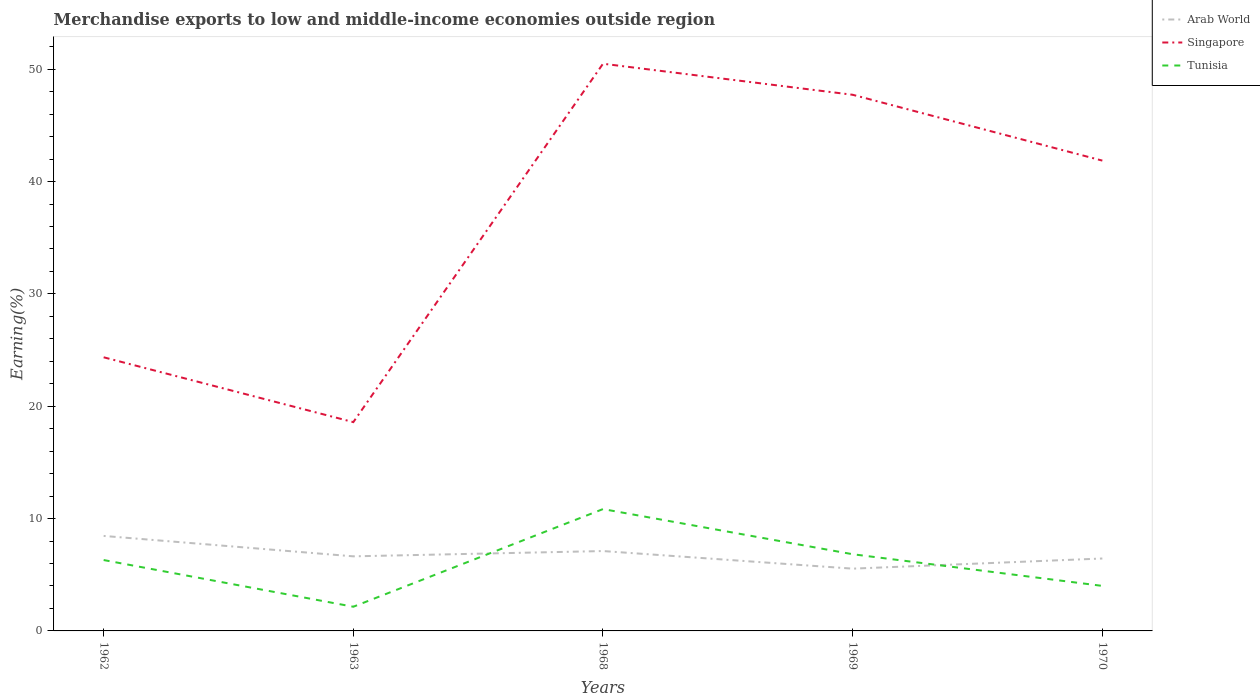How many different coloured lines are there?
Your answer should be very brief. 3. Does the line corresponding to Singapore intersect with the line corresponding to Arab World?
Make the answer very short. No. Across all years, what is the maximum percentage of amount earned from merchandise exports in Singapore?
Make the answer very short. 18.59. In which year was the percentage of amount earned from merchandise exports in Singapore maximum?
Offer a very short reply. 1963. What is the total percentage of amount earned from merchandise exports in Arab World in the graph?
Ensure brevity in your answer.  2.91. What is the difference between the highest and the second highest percentage of amount earned from merchandise exports in Singapore?
Your answer should be very brief. 31.9. Does the graph contain any zero values?
Give a very brief answer. No. Where does the legend appear in the graph?
Keep it short and to the point. Top right. How many legend labels are there?
Offer a terse response. 3. What is the title of the graph?
Offer a very short reply. Merchandise exports to low and middle-income economies outside region. Does "Cayman Islands" appear as one of the legend labels in the graph?
Your answer should be compact. No. What is the label or title of the X-axis?
Provide a short and direct response. Years. What is the label or title of the Y-axis?
Make the answer very short. Earning(%). What is the Earning(%) of Arab World in 1962?
Offer a very short reply. 8.46. What is the Earning(%) of Singapore in 1962?
Keep it short and to the point. 24.36. What is the Earning(%) in Tunisia in 1962?
Your answer should be compact. 6.31. What is the Earning(%) of Arab World in 1963?
Offer a very short reply. 6.64. What is the Earning(%) in Singapore in 1963?
Offer a very short reply. 18.59. What is the Earning(%) in Tunisia in 1963?
Your answer should be very brief. 2.15. What is the Earning(%) of Arab World in 1968?
Ensure brevity in your answer.  7.11. What is the Earning(%) of Singapore in 1968?
Make the answer very short. 50.49. What is the Earning(%) of Tunisia in 1968?
Your answer should be compact. 10.85. What is the Earning(%) in Arab World in 1969?
Keep it short and to the point. 5.54. What is the Earning(%) of Singapore in 1969?
Make the answer very short. 47.73. What is the Earning(%) in Tunisia in 1969?
Offer a very short reply. 6.83. What is the Earning(%) of Arab World in 1970?
Your answer should be compact. 6.45. What is the Earning(%) in Singapore in 1970?
Make the answer very short. 41.87. What is the Earning(%) in Tunisia in 1970?
Your answer should be compact. 4.01. Across all years, what is the maximum Earning(%) in Arab World?
Ensure brevity in your answer.  8.46. Across all years, what is the maximum Earning(%) in Singapore?
Make the answer very short. 50.49. Across all years, what is the maximum Earning(%) of Tunisia?
Provide a short and direct response. 10.85. Across all years, what is the minimum Earning(%) of Arab World?
Your answer should be compact. 5.54. Across all years, what is the minimum Earning(%) of Singapore?
Offer a very short reply. 18.59. Across all years, what is the minimum Earning(%) of Tunisia?
Provide a short and direct response. 2.15. What is the total Earning(%) in Arab World in the graph?
Your answer should be very brief. 34.2. What is the total Earning(%) in Singapore in the graph?
Offer a very short reply. 183.04. What is the total Earning(%) of Tunisia in the graph?
Keep it short and to the point. 30.14. What is the difference between the Earning(%) in Arab World in 1962 and that in 1963?
Your answer should be compact. 1.82. What is the difference between the Earning(%) of Singapore in 1962 and that in 1963?
Provide a succinct answer. 5.77. What is the difference between the Earning(%) of Tunisia in 1962 and that in 1963?
Keep it short and to the point. 4.16. What is the difference between the Earning(%) of Arab World in 1962 and that in 1968?
Offer a very short reply. 1.35. What is the difference between the Earning(%) in Singapore in 1962 and that in 1968?
Your answer should be very brief. -26.13. What is the difference between the Earning(%) in Tunisia in 1962 and that in 1968?
Keep it short and to the point. -4.54. What is the difference between the Earning(%) in Arab World in 1962 and that in 1969?
Provide a short and direct response. 2.91. What is the difference between the Earning(%) in Singapore in 1962 and that in 1969?
Give a very brief answer. -23.37. What is the difference between the Earning(%) in Tunisia in 1962 and that in 1969?
Give a very brief answer. -0.52. What is the difference between the Earning(%) in Arab World in 1962 and that in 1970?
Make the answer very short. 2.01. What is the difference between the Earning(%) in Singapore in 1962 and that in 1970?
Make the answer very short. -17.51. What is the difference between the Earning(%) in Tunisia in 1962 and that in 1970?
Your response must be concise. 2.3. What is the difference between the Earning(%) of Arab World in 1963 and that in 1968?
Give a very brief answer. -0.47. What is the difference between the Earning(%) in Singapore in 1963 and that in 1968?
Offer a very short reply. -31.9. What is the difference between the Earning(%) in Tunisia in 1963 and that in 1968?
Make the answer very short. -8.69. What is the difference between the Earning(%) of Arab World in 1963 and that in 1969?
Your answer should be very brief. 1.1. What is the difference between the Earning(%) in Singapore in 1963 and that in 1969?
Offer a terse response. -29.14. What is the difference between the Earning(%) of Tunisia in 1963 and that in 1969?
Your answer should be very brief. -4.67. What is the difference between the Earning(%) of Arab World in 1963 and that in 1970?
Ensure brevity in your answer.  0.19. What is the difference between the Earning(%) in Singapore in 1963 and that in 1970?
Your answer should be very brief. -23.28. What is the difference between the Earning(%) of Tunisia in 1963 and that in 1970?
Your answer should be very brief. -1.86. What is the difference between the Earning(%) in Arab World in 1968 and that in 1969?
Your answer should be very brief. 1.57. What is the difference between the Earning(%) of Singapore in 1968 and that in 1969?
Your answer should be very brief. 2.76. What is the difference between the Earning(%) in Tunisia in 1968 and that in 1969?
Offer a very short reply. 4.02. What is the difference between the Earning(%) in Arab World in 1968 and that in 1970?
Provide a short and direct response. 0.66. What is the difference between the Earning(%) in Singapore in 1968 and that in 1970?
Your answer should be very brief. 8.62. What is the difference between the Earning(%) in Tunisia in 1968 and that in 1970?
Provide a short and direct response. 6.84. What is the difference between the Earning(%) of Arab World in 1969 and that in 1970?
Offer a very short reply. -0.9. What is the difference between the Earning(%) of Singapore in 1969 and that in 1970?
Give a very brief answer. 5.86. What is the difference between the Earning(%) in Tunisia in 1969 and that in 1970?
Offer a very short reply. 2.82. What is the difference between the Earning(%) of Arab World in 1962 and the Earning(%) of Singapore in 1963?
Offer a terse response. -10.13. What is the difference between the Earning(%) in Arab World in 1962 and the Earning(%) in Tunisia in 1963?
Offer a very short reply. 6.3. What is the difference between the Earning(%) of Singapore in 1962 and the Earning(%) of Tunisia in 1963?
Your response must be concise. 22.21. What is the difference between the Earning(%) of Arab World in 1962 and the Earning(%) of Singapore in 1968?
Provide a succinct answer. -42.04. What is the difference between the Earning(%) in Arab World in 1962 and the Earning(%) in Tunisia in 1968?
Make the answer very short. -2.39. What is the difference between the Earning(%) in Singapore in 1962 and the Earning(%) in Tunisia in 1968?
Your response must be concise. 13.51. What is the difference between the Earning(%) of Arab World in 1962 and the Earning(%) of Singapore in 1969?
Offer a terse response. -39.27. What is the difference between the Earning(%) in Arab World in 1962 and the Earning(%) in Tunisia in 1969?
Provide a short and direct response. 1.63. What is the difference between the Earning(%) of Singapore in 1962 and the Earning(%) of Tunisia in 1969?
Your response must be concise. 17.53. What is the difference between the Earning(%) of Arab World in 1962 and the Earning(%) of Singapore in 1970?
Make the answer very short. -33.41. What is the difference between the Earning(%) in Arab World in 1962 and the Earning(%) in Tunisia in 1970?
Provide a short and direct response. 4.45. What is the difference between the Earning(%) in Singapore in 1962 and the Earning(%) in Tunisia in 1970?
Offer a very short reply. 20.35. What is the difference between the Earning(%) of Arab World in 1963 and the Earning(%) of Singapore in 1968?
Give a very brief answer. -43.85. What is the difference between the Earning(%) in Arab World in 1963 and the Earning(%) in Tunisia in 1968?
Keep it short and to the point. -4.21. What is the difference between the Earning(%) of Singapore in 1963 and the Earning(%) of Tunisia in 1968?
Keep it short and to the point. 7.74. What is the difference between the Earning(%) in Arab World in 1963 and the Earning(%) in Singapore in 1969?
Provide a short and direct response. -41.09. What is the difference between the Earning(%) of Arab World in 1963 and the Earning(%) of Tunisia in 1969?
Your answer should be compact. -0.19. What is the difference between the Earning(%) of Singapore in 1963 and the Earning(%) of Tunisia in 1969?
Ensure brevity in your answer.  11.76. What is the difference between the Earning(%) in Arab World in 1963 and the Earning(%) in Singapore in 1970?
Give a very brief answer. -35.23. What is the difference between the Earning(%) in Arab World in 1963 and the Earning(%) in Tunisia in 1970?
Your response must be concise. 2.63. What is the difference between the Earning(%) of Singapore in 1963 and the Earning(%) of Tunisia in 1970?
Make the answer very short. 14.58. What is the difference between the Earning(%) in Arab World in 1968 and the Earning(%) in Singapore in 1969?
Your answer should be compact. -40.62. What is the difference between the Earning(%) of Arab World in 1968 and the Earning(%) of Tunisia in 1969?
Offer a very short reply. 0.28. What is the difference between the Earning(%) in Singapore in 1968 and the Earning(%) in Tunisia in 1969?
Your response must be concise. 43.67. What is the difference between the Earning(%) of Arab World in 1968 and the Earning(%) of Singapore in 1970?
Ensure brevity in your answer.  -34.76. What is the difference between the Earning(%) of Arab World in 1968 and the Earning(%) of Tunisia in 1970?
Offer a terse response. 3.1. What is the difference between the Earning(%) of Singapore in 1968 and the Earning(%) of Tunisia in 1970?
Your answer should be very brief. 46.48. What is the difference between the Earning(%) in Arab World in 1969 and the Earning(%) in Singapore in 1970?
Your answer should be compact. -36.32. What is the difference between the Earning(%) in Arab World in 1969 and the Earning(%) in Tunisia in 1970?
Your response must be concise. 1.54. What is the difference between the Earning(%) in Singapore in 1969 and the Earning(%) in Tunisia in 1970?
Make the answer very short. 43.72. What is the average Earning(%) of Arab World per year?
Provide a succinct answer. 6.84. What is the average Earning(%) in Singapore per year?
Give a very brief answer. 36.61. What is the average Earning(%) of Tunisia per year?
Keep it short and to the point. 6.03. In the year 1962, what is the difference between the Earning(%) in Arab World and Earning(%) in Singapore?
Provide a short and direct response. -15.9. In the year 1962, what is the difference between the Earning(%) of Arab World and Earning(%) of Tunisia?
Provide a succinct answer. 2.15. In the year 1962, what is the difference between the Earning(%) of Singapore and Earning(%) of Tunisia?
Offer a terse response. 18.05. In the year 1963, what is the difference between the Earning(%) of Arab World and Earning(%) of Singapore?
Make the answer very short. -11.95. In the year 1963, what is the difference between the Earning(%) of Arab World and Earning(%) of Tunisia?
Offer a terse response. 4.49. In the year 1963, what is the difference between the Earning(%) of Singapore and Earning(%) of Tunisia?
Offer a very short reply. 16.43. In the year 1968, what is the difference between the Earning(%) in Arab World and Earning(%) in Singapore?
Your answer should be very brief. -43.38. In the year 1968, what is the difference between the Earning(%) in Arab World and Earning(%) in Tunisia?
Your answer should be very brief. -3.74. In the year 1968, what is the difference between the Earning(%) of Singapore and Earning(%) of Tunisia?
Provide a short and direct response. 39.65. In the year 1969, what is the difference between the Earning(%) in Arab World and Earning(%) in Singapore?
Keep it short and to the point. -42.18. In the year 1969, what is the difference between the Earning(%) of Arab World and Earning(%) of Tunisia?
Keep it short and to the point. -1.28. In the year 1969, what is the difference between the Earning(%) of Singapore and Earning(%) of Tunisia?
Ensure brevity in your answer.  40.9. In the year 1970, what is the difference between the Earning(%) in Arab World and Earning(%) in Singapore?
Your answer should be compact. -35.42. In the year 1970, what is the difference between the Earning(%) of Arab World and Earning(%) of Tunisia?
Your answer should be compact. 2.44. In the year 1970, what is the difference between the Earning(%) in Singapore and Earning(%) in Tunisia?
Your response must be concise. 37.86. What is the ratio of the Earning(%) in Arab World in 1962 to that in 1963?
Offer a very short reply. 1.27. What is the ratio of the Earning(%) of Singapore in 1962 to that in 1963?
Make the answer very short. 1.31. What is the ratio of the Earning(%) of Tunisia in 1962 to that in 1963?
Provide a succinct answer. 2.93. What is the ratio of the Earning(%) of Arab World in 1962 to that in 1968?
Keep it short and to the point. 1.19. What is the ratio of the Earning(%) of Singapore in 1962 to that in 1968?
Your answer should be compact. 0.48. What is the ratio of the Earning(%) of Tunisia in 1962 to that in 1968?
Keep it short and to the point. 0.58. What is the ratio of the Earning(%) of Arab World in 1962 to that in 1969?
Provide a short and direct response. 1.53. What is the ratio of the Earning(%) in Singapore in 1962 to that in 1969?
Your answer should be compact. 0.51. What is the ratio of the Earning(%) of Tunisia in 1962 to that in 1969?
Offer a terse response. 0.92. What is the ratio of the Earning(%) in Arab World in 1962 to that in 1970?
Provide a short and direct response. 1.31. What is the ratio of the Earning(%) of Singapore in 1962 to that in 1970?
Ensure brevity in your answer.  0.58. What is the ratio of the Earning(%) of Tunisia in 1962 to that in 1970?
Your answer should be very brief. 1.57. What is the ratio of the Earning(%) in Arab World in 1963 to that in 1968?
Your answer should be compact. 0.93. What is the ratio of the Earning(%) of Singapore in 1963 to that in 1968?
Your answer should be very brief. 0.37. What is the ratio of the Earning(%) in Tunisia in 1963 to that in 1968?
Your response must be concise. 0.2. What is the ratio of the Earning(%) of Arab World in 1963 to that in 1969?
Make the answer very short. 1.2. What is the ratio of the Earning(%) of Singapore in 1963 to that in 1969?
Offer a terse response. 0.39. What is the ratio of the Earning(%) in Tunisia in 1963 to that in 1969?
Offer a terse response. 0.32. What is the ratio of the Earning(%) of Arab World in 1963 to that in 1970?
Provide a succinct answer. 1.03. What is the ratio of the Earning(%) of Singapore in 1963 to that in 1970?
Keep it short and to the point. 0.44. What is the ratio of the Earning(%) of Tunisia in 1963 to that in 1970?
Make the answer very short. 0.54. What is the ratio of the Earning(%) of Arab World in 1968 to that in 1969?
Your answer should be very brief. 1.28. What is the ratio of the Earning(%) in Singapore in 1968 to that in 1969?
Your answer should be compact. 1.06. What is the ratio of the Earning(%) in Tunisia in 1968 to that in 1969?
Give a very brief answer. 1.59. What is the ratio of the Earning(%) in Arab World in 1968 to that in 1970?
Give a very brief answer. 1.1. What is the ratio of the Earning(%) of Singapore in 1968 to that in 1970?
Give a very brief answer. 1.21. What is the ratio of the Earning(%) of Tunisia in 1968 to that in 1970?
Ensure brevity in your answer.  2.71. What is the ratio of the Earning(%) of Arab World in 1969 to that in 1970?
Your answer should be compact. 0.86. What is the ratio of the Earning(%) of Singapore in 1969 to that in 1970?
Provide a short and direct response. 1.14. What is the ratio of the Earning(%) in Tunisia in 1969 to that in 1970?
Provide a succinct answer. 1.7. What is the difference between the highest and the second highest Earning(%) of Arab World?
Offer a terse response. 1.35. What is the difference between the highest and the second highest Earning(%) in Singapore?
Provide a short and direct response. 2.76. What is the difference between the highest and the second highest Earning(%) of Tunisia?
Offer a terse response. 4.02. What is the difference between the highest and the lowest Earning(%) in Arab World?
Keep it short and to the point. 2.91. What is the difference between the highest and the lowest Earning(%) of Singapore?
Make the answer very short. 31.9. What is the difference between the highest and the lowest Earning(%) of Tunisia?
Provide a short and direct response. 8.69. 